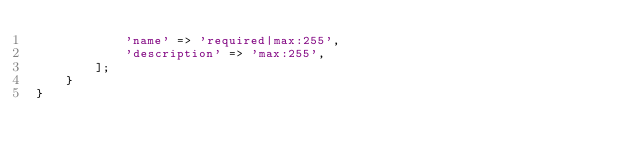<code> <loc_0><loc_0><loc_500><loc_500><_PHP_>            'name' => 'required|max:255',
            'description' => 'max:255',
        ];
    }
}

</code> 